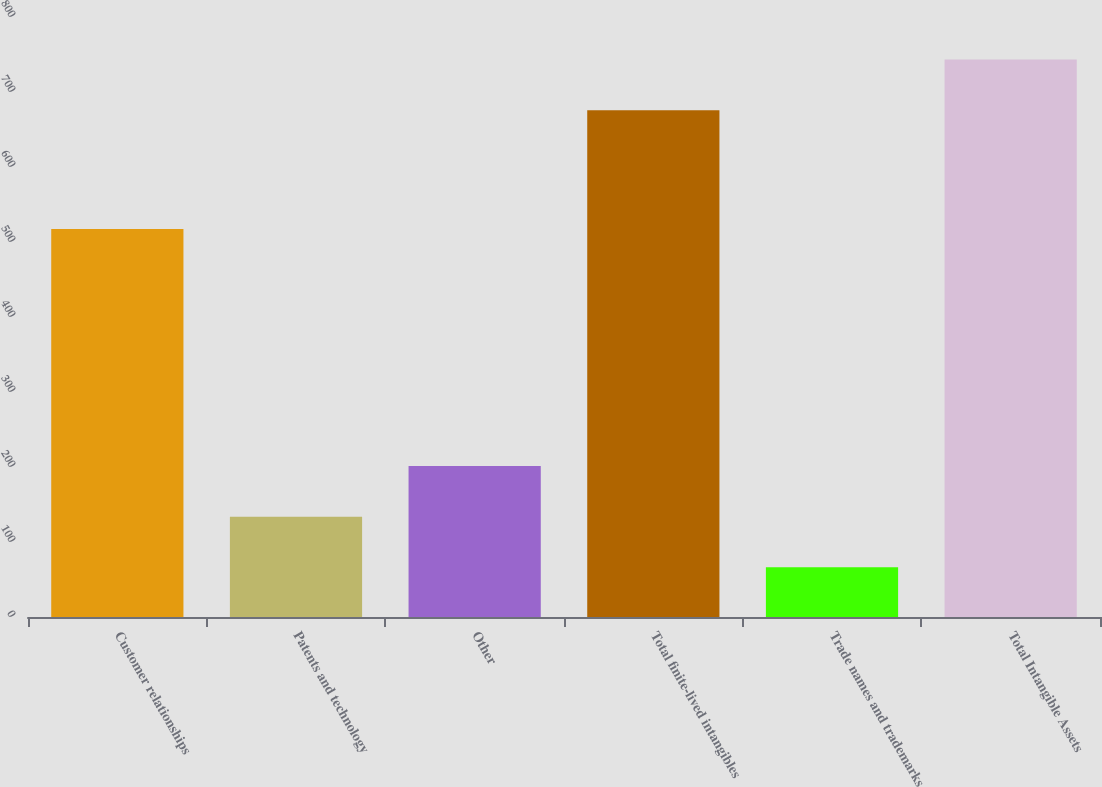<chart> <loc_0><loc_0><loc_500><loc_500><bar_chart><fcel>Customer relationships<fcel>Patents and technology<fcel>Other<fcel>Total finite-lived intangibles<fcel>Trade names and trademarks<fcel>Total Intangible Assets<nl><fcel>517.4<fcel>133.77<fcel>201.34<fcel>675.7<fcel>66.2<fcel>743.27<nl></chart> 